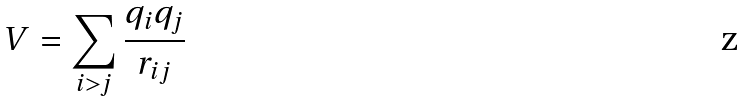<formula> <loc_0><loc_0><loc_500><loc_500>V = \sum _ { i > j } { \frac { q _ { i } q _ { j } } { r _ { i j } } }</formula> 